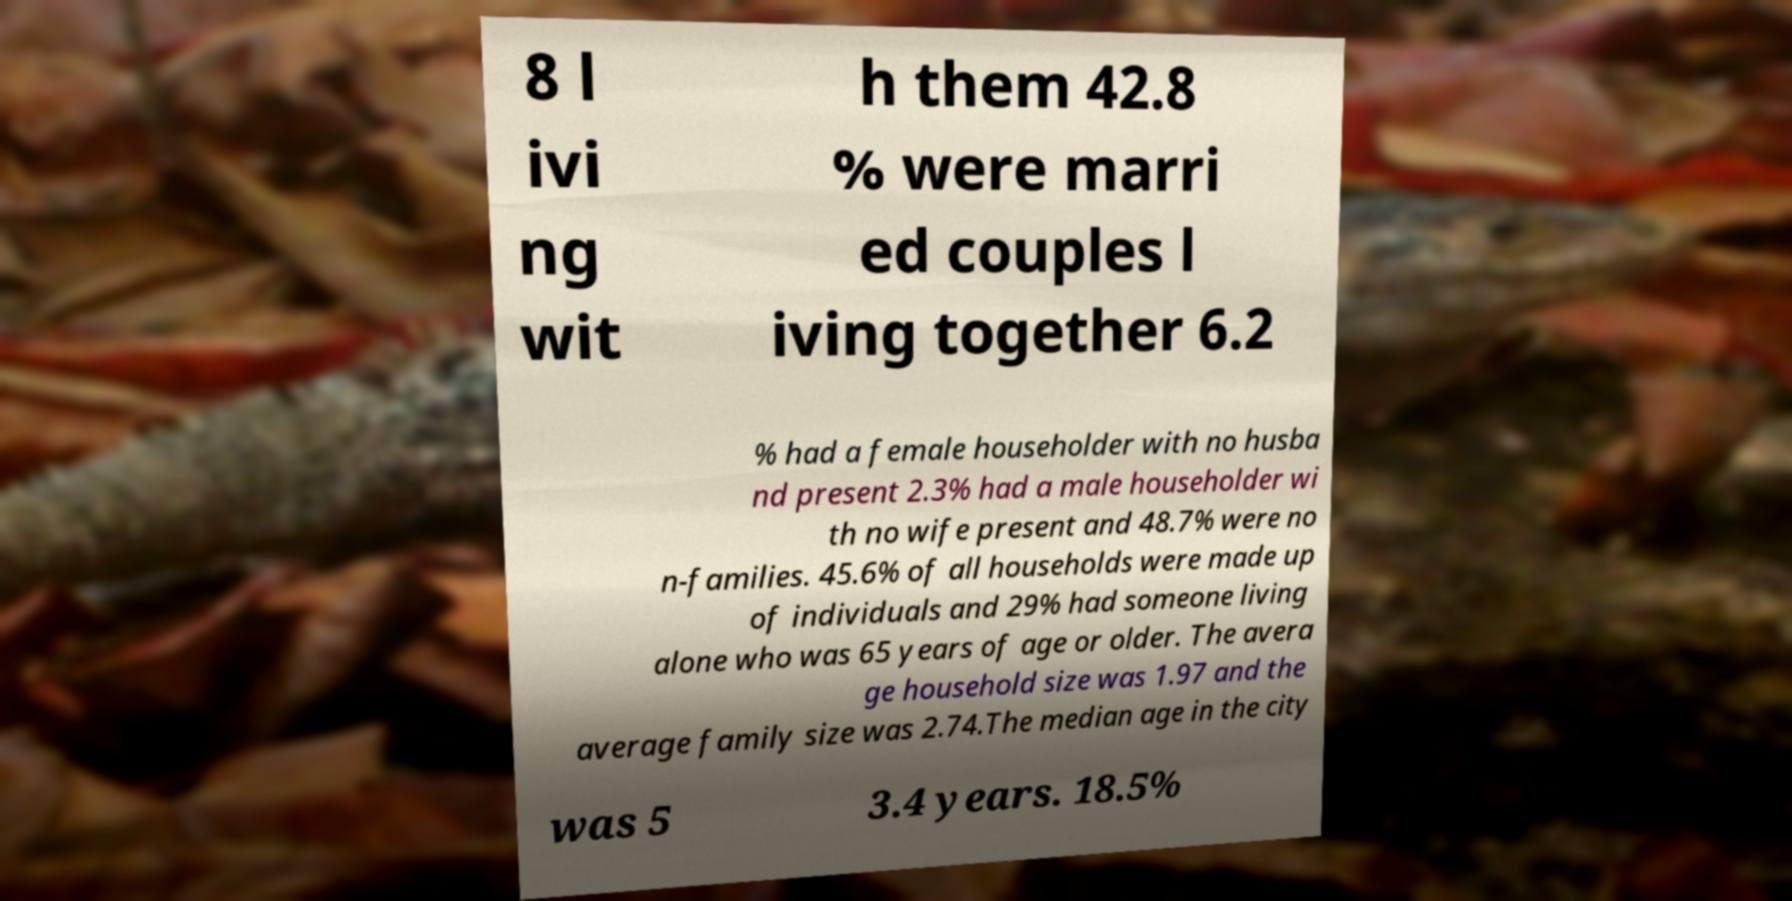There's text embedded in this image that I need extracted. Can you transcribe it verbatim? 8 l ivi ng wit h them 42.8 % were marri ed couples l iving together 6.2 % had a female householder with no husba nd present 2.3% had a male householder wi th no wife present and 48.7% were no n-families. 45.6% of all households were made up of individuals and 29% had someone living alone who was 65 years of age or older. The avera ge household size was 1.97 and the average family size was 2.74.The median age in the city was 5 3.4 years. 18.5% 